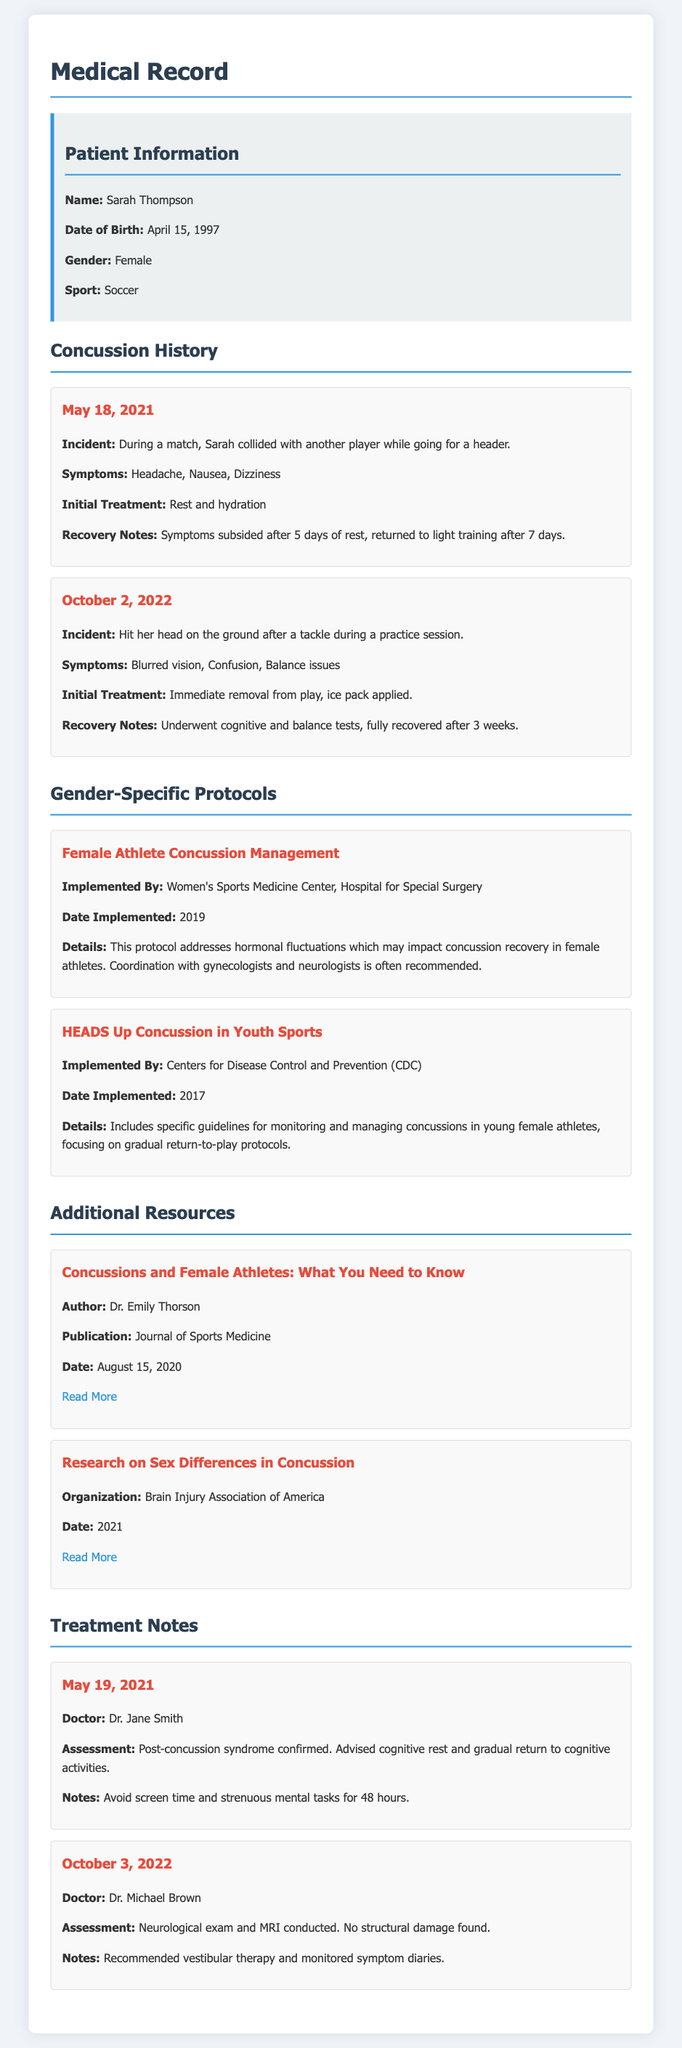What is Sarah Thompson's date of birth? The date of birth is mentioned in the patient information section of the document.
Answer: April 15, 1997 What sport does Sarah play? The sport is specified in the patient information section of the document.
Answer: Soccer What were the symptoms following the incident on October 2, 2022? The symptoms are listed under the concussion history for the incident on that date.
Answer: Blurred vision, Confusion, Balance issues Who oversaw the implementation of the Female Athlete Concussion Management protocol? The document indicates who implemented this specific protocol in the gender-specific protocols section.
Answer: Women's Sports Medicine Center, Hospital for Special Surgery How many days did it take for Sarah to return to light training after her first concussion? This information is provided in the recovery notes of her first concussion incident.
Answer: 7 days What assessment was made by Dr. Jane Smith on May 19, 2021? The assessment is mentioned in the treatment notes associated with Dr. Jane Smith.
Answer: Post-concussion syndrome confirmed Which organization published research on sex differences in concussion? The organization is identified in the additional resources section of the document.
Answer: Brain Injury Association of America What therapy was recommended after the neurological exam on October 3, 2022? This recommendation is included in the treatment notes for that date.
Answer: Vestibular therapy 